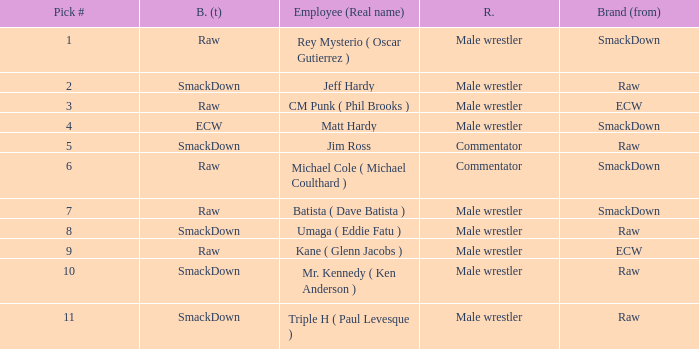What role did Pick # 10 have? Male wrestler. 